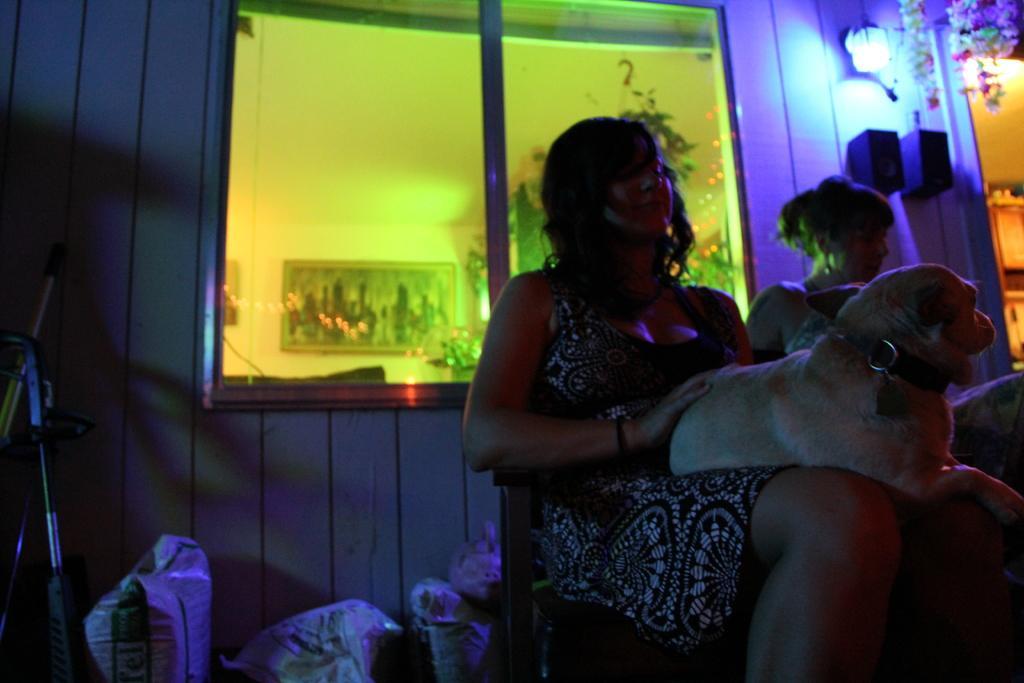Could you give a brief overview of what you see in this image? In this image we can see two persons. There are many objects on the ground. There is a dog in the image. There is a photo frame on the wall. There are lamps in the image. 